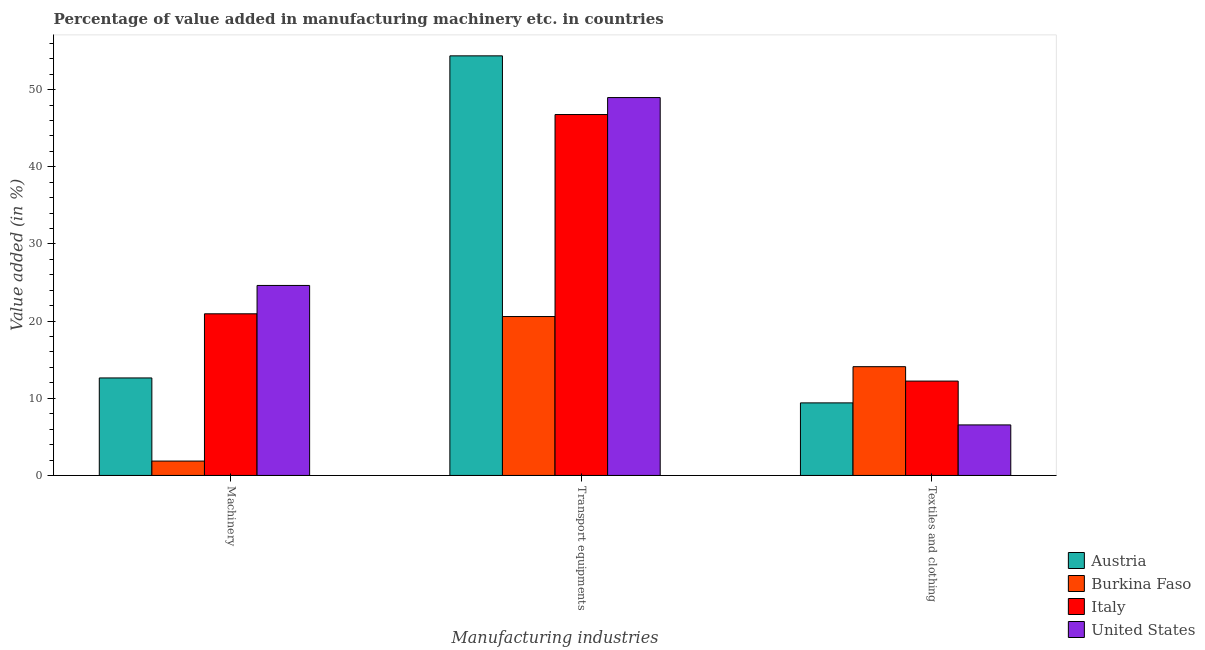How many groups of bars are there?
Provide a succinct answer. 3. How many bars are there on the 2nd tick from the left?
Ensure brevity in your answer.  4. What is the label of the 1st group of bars from the left?
Make the answer very short. Machinery. What is the value added in manufacturing machinery in United States?
Keep it short and to the point. 24.63. Across all countries, what is the maximum value added in manufacturing transport equipments?
Your answer should be compact. 54.38. Across all countries, what is the minimum value added in manufacturing machinery?
Give a very brief answer. 1.86. What is the total value added in manufacturing transport equipments in the graph?
Your answer should be very brief. 170.74. What is the difference between the value added in manufacturing machinery in Austria and that in Burkina Faso?
Provide a succinct answer. 10.77. What is the difference between the value added in manufacturing machinery in United States and the value added in manufacturing transport equipments in Austria?
Your answer should be compact. -29.76. What is the average value added in manufacturing textile and clothing per country?
Make the answer very short. 10.57. What is the difference between the value added in manufacturing transport equipments and value added in manufacturing textile and clothing in Burkina Faso?
Your answer should be compact. 6.5. In how many countries, is the value added in manufacturing transport equipments greater than 28 %?
Ensure brevity in your answer.  3. What is the ratio of the value added in manufacturing textile and clothing in United States to that in Italy?
Give a very brief answer. 0.54. Is the difference between the value added in manufacturing textile and clothing in United States and Austria greater than the difference between the value added in manufacturing transport equipments in United States and Austria?
Keep it short and to the point. Yes. What is the difference between the highest and the second highest value added in manufacturing textile and clothing?
Give a very brief answer. 1.87. What is the difference between the highest and the lowest value added in manufacturing machinery?
Keep it short and to the point. 22.76. What does the 3rd bar from the right in Textiles and clothing represents?
Provide a short and direct response. Burkina Faso. What is the difference between two consecutive major ticks on the Y-axis?
Make the answer very short. 10. Are the values on the major ticks of Y-axis written in scientific E-notation?
Your answer should be compact. No. Does the graph contain any zero values?
Give a very brief answer. No. Does the graph contain grids?
Offer a very short reply. No. How are the legend labels stacked?
Provide a short and direct response. Vertical. What is the title of the graph?
Make the answer very short. Percentage of value added in manufacturing machinery etc. in countries. Does "Afghanistan" appear as one of the legend labels in the graph?
Ensure brevity in your answer.  No. What is the label or title of the X-axis?
Make the answer very short. Manufacturing industries. What is the label or title of the Y-axis?
Make the answer very short. Value added (in %). What is the Value added (in %) in Austria in Machinery?
Keep it short and to the point. 12.64. What is the Value added (in %) in Burkina Faso in Machinery?
Give a very brief answer. 1.86. What is the Value added (in %) in Italy in Machinery?
Provide a succinct answer. 20.95. What is the Value added (in %) of United States in Machinery?
Give a very brief answer. 24.63. What is the Value added (in %) in Austria in Transport equipments?
Provide a short and direct response. 54.38. What is the Value added (in %) in Burkina Faso in Transport equipments?
Ensure brevity in your answer.  20.6. What is the Value added (in %) in Italy in Transport equipments?
Your answer should be very brief. 46.78. What is the Value added (in %) in United States in Transport equipments?
Make the answer very short. 48.98. What is the Value added (in %) in Austria in Textiles and clothing?
Your response must be concise. 9.4. What is the Value added (in %) in Burkina Faso in Textiles and clothing?
Your answer should be very brief. 14.1. What is the Value added (in %) in Italy in Textiles and clothing?
Offer a terse response. 12.23. What is the Value added (in %) in United States in Textiles and clothing?
Make the answer very short. 6.55. Across all Manufacturing industries, what is the maximum Value added (in %) in Austria?
Your answer should be compact. 54.38. Across all Manufacturing industries, what is the maximum Value added (in %) of Burkina Faso?
Provide a succinct answer. 20.6. Across all Manufacturing industries, what is the maximum Value added (in %) in Italy?
Keep it short and to the point. 46.78. Across all Manufacturing industries, what is the maximum Value added (in %) in United States?
Your answer should be compact. 48.98. Across all Manufacturing industries, what is the minimum Value added (in %) of Austria?
Your answer should be very brief. 9.4. Across all Manufacturing industries, what is the minimum Value added (in %) in Burkina Faso?
Make the answer very short. 1.86. Across all Manufacturing industries, what is the minimum Value added (in %) in Italy?
Ensure brevity in your answer.  12.23. Across all Manufacturing industries, what is the minimum Value added (in %) in United States?
Provide a succinct answer. 6.55. What is the total Value added (in %) of Austria in the graph?
Make the answer very short. 76.43. What is the total Value added (in %) in Burkina Faso in the graph?
Provide a succinct answer. 36.56. What is the total Value added (in %) in Italy in the graph?
Provide a short and direct response. 79.96. What is the total Value added (in %) of United States in the graph?
Your answer should be compact. 80.15. What is the difference between the Value added (in %) of Austria in Machinery and that in Transport equipments?
Offer a terse response. -41.75. What is the difference between the Value added (in %) in Burkina Faso in Machinery and that in Transport equipments?
Provide a short and direct response. -18.73. What is the difference between the Value added (in %) in Italy in Machinery and that in Transport equipments?
Offer a terse response. -25.83. What is the difference between the Value added (in %) of United States in Machinery and that in Transport equipments?
Provide a short and direct response. -24.35. What is the difference between the Value added (in %) in Austria in Machinery and that in Textiles and clothing?
Offer a terse response. 3.23. What is the difference between the Value added (in %) of Burkina Faso in Machinery and that in Textiles and clothing?
Provide a short and direct response. -12.23. What is the difference between the Value added (in %) in Italy in Machinery and that in Textiles and clothing?
Your answer should be compact. 8.72. What is the difference between the Value added (in %) in United States in Machinery and that in Textiles and clothing?
Provide a short and direct response. 18.08. What is the difference between the Value added (in %) in Austria in Transport equipments and that in Textiles and clothing?
Ensure brevity in your answer.  44.98. What is the difference between the Value added (in %) in Burkina Faso in Transport equipments and that in Textiles and clothing?
Give a very brief answer. 6.5. What is the difference between the Value added (in %) in Italy in Transport equipments and that in Textiles and clothing?
Make the answer very short. 34.55. What is the difference between the Value added (in %) of United States in Transport equipments and that in Textiles and clothing?
Keep it short and to the point. 42.43. What is the difference between the Value added (in %) of Austria in Machinery and the Value added (in %) of Burkina Faso in Transport equipments?
Offer a terse response. -7.96. What is the difference between the Value added (in %) in Austria in Machinery and the Value added (in %) in Italy in Transport equipments?
Make the answer very short. -34.14. What is the difference between the Value added (in %) of Austria in Machinery and the Value added (in %) of United States in Transport equipments?
Provide a succinct answer. -36.34. What is the difference between the Value added (in %) in Burkina Faso in Machinery and the Value added (in %) in Italy in Transport equipments?
Your answer should be compact. -44.91. What is the difference between the Value added (in %) in Burkina Faso in Machinery and the Value added (in %) in United States in Transport equipments?
Give a very brief answer. -47.11. What is the difference between the Value added (in %) of Italy in Machinery and the Value added (in %) of United States in Transport equipments?
Your answer should be very brief. -28.03. What is the difference between the Value added (in %) of Austria in Machinery and the Value added (in %) of Burkina Faso in Textiles and clothing?
Keep it short and to the point. -1.46. What is the difference between the Value added (in %) in Austria in Machinery and the Value added (in %) in Italy in Textiles and clothing?
Make the answer very short. 0.41. What is the difference between the Value added (in %) in Austria in Machinery and the Value added (in %) in United States in Textiles and clothing?
Your answer should be very brief. 6.09. What is the difference between the Value added (in %) in Burkina Faso in Machinery and the Value added (in %) in Italy in Textiles and clothing?
Your response must be concise. -10.37. What is the difference between the Value added (in %) of Burkina Faso in Machinery and the Value added (in %) of United States in Textiles and clothing?
Your answer should be compact. -4.69. What is the difference between the Value added (in %) of Italy in Machinery and the Value added (in %) of United States in Textiles and clothing?
Provide a short and direct response. 14.4. What is the difference between the Value added (in %) in Austria in Transport equipments and the Value added (in %) in Burkina Faso in Textiles and clothing?
Keep it short and to the point. 40.29. What is the difference between the Value added (in %) of Austria in Transport equipments and the Value added (in %) of Italy in Textiles and clothing?
Ensure brevity in your answer.  42.15. What is the difference between the Value added (in %) in Austria in Transport equipments and the Value added (in %) in United States in Textiles and clothing?
Your response must be concise. 47.83. What is the difference between the Value added (in %) of Burkina Faso in Transport equipments and the Value added (in %) of Italy in Textiles and clothing?
Provide a succinct answer. 8.37. What is the difference between the Value added (in %) in Burkina Faso in Transport equipments and the Value added (in %) in United States in Textiles and clothing?
Make the answer very short. 14.05. What is the difference between the Value added (in %) of Italy in Transport equipments and the Value added (in %) of United States in Textiles and clothing?
Keep it short and to the point. 40.23. What is the average Value added (in %) in Austria per Manufacturing industries?
Keep it short and to the point. 25.48. What is the average Value added (in %) of Burkina Faso per Manufacturing industries?
Offer a very short reply. 12.19. What is the average Value added (in %) of Italy per Manufacturing industries?
Make the answer very short. 26.65. What is the average Value added (in %) of United States per Manufacturing industries?
Keep it short and to the point. 26.72. What is the difference between the Value added (in %) in Austria and Value added (in %) in Burkina Faso in Machinery?
Provide a succinct answer. 10.77. What is the difference between the Value added (in %) in Austria and Value added (in %) in Italy in Machinery?
Your response must be concise. -8.31. What is the difference between the Value added (in %) in Austria and Value added (in %) in United States in Machinery?
Provide a succinct answer. -11.99. What is the difference between the Value added (in %) in Burkina Faso and Value added (in %) in Italy in Machinery?
Offer a terse response. -19.09. What is the difference between the Value added (in %) in Burkina Faso and Value added (in %) in United States in Machinery?
Your answer should be compact. -22.76. What is the difference between the Value added (in %) in Italy and Value added (in %) in United States in Machinery?
Keep it short and to the point. -3.68. What is the difference between the Value added (in %) in Austria and Value added (in %) in Burkina Faso in Transport equipments?
Ensure brevity in your answer.  33.79. What is the difference between the Value added (in %) in Austria and Value added (in %) in Italy in Transport equipments?
Provide a succinct answer. 7.61. What is the difference between the Value added (in %) of Austria and Value added (in %) of United States in Transport equipments?
Your answer should be compact. 5.41. What is the difference between the Value added (in %) of Burkina Faso and Value added (in %) of Italy in Transport equipments?
Your answer should be compact. -26.18. What is the difference between the Value added (in %) of Burkina Faso and Value added (in %) of United States in Transport equipments?
Offer a very short reply. -28.38. What is the difference between the Value added (in %) of Italy and Value added (in %) of United States in Transport equipments?
Your response must be concise. -2.2. What is the difference between the Value added (in %) of Austria and Value added (in %) of Burkina Faso in Textiles and clothing?
Ensure brevity in your answer.  -4.69. What is the difference between the Value added (in %) in Austria and Value added (in %) in Italy in Textiles and clothing?
Ensure brevity in your answer.  -2.82. What is the difference between the Value added (in %) in Austria and Value added (in %) in United States in Textiles and clothing?
Provide a short and direct response. 2.86. What is the difference between the Value added (in %) in Burkina Faso and Value added (in %) in Italy in Textiles and clothing?
Your answer should be compact. 1.87. What is the difference between the Value added (in %) in Burkina Faso and Value added (in %) in United States in Textiles and clothing?
Ensure brevity in your answer.  7.55. What is the difference between the Value added (in %) of Italy and Value added (in %) of United States in Textiles and clothing?
Your answer should be compact. 5.68. What is the ratio of the Value added (in %) in Austria in Machinery to that in Transport equipments?
Provide a short and direct response. 0.23. What is the ratio of the Value added (in %) in Burkina Faso in Machinery to that in Transport equipments?
Provide a succinct answer. 0.09. What is the ratio of the Value added (in %) in Italy in Machinery to that in Transport equipments?
Your answer should be very brief. 0.45. What is the ratio of the Value added (in %) of United States in Machinery to that in Transport equipments?
Give a very brief answer. 0.5. What is the ratio of the Value added (in %) of Austria in Machinery to that in Textiles and clothing?
Your response must be concise. 1.34. What is the ratio of the Value added (in %) of Burkina Faso in Machinery to that in Textiles and clothing?
Ensure brevity in your answer.  0.13. What is the ratio of the Value added (in %) in Italy in Machinery to that in Textiles and clothing?
Provide a short and direct response. 1.71. What is the ratio of the Value added (in %) in United States in Machinery to that in Textiles and clothing?
Ensure brevity in your answer.  3.76. What is the ratio of the Value added (in %) of Austria in Transport equipments to that in Textiles and clothing?
Make the answer very short. 5.78. What is the ratio of the Value added (in %) of Burkina Faso in Transport equipments to that in Textiles and clothing?
Your response must be concise. 1.46. What is the ratio of the Value added (in %) of Italy in Transport equipments to that in Textiles and clothing?
Give a very brief answer. 3.83. What is the ratio of the Value added (in %) in United States in Transport equipments to that in Textiles and clothing?
Keep it short and to the point. 7.48. What is the difference between the highest and the second highest Value added (in %) in Austria?
Provide a succinct answer. 41.75. What is the difference between the highest and the second highest Value added (in %) of Burkina Faso?
Keep it short and to the point. 6.5. What is the difference between the highest and the second highest Value added (in %) in Italy?
Offer a terse response. 25.83. What is the difference between the highest and the second highest Value added (in %) of United States?
Offer a very short reply. 24.35. What is the difference between the highest and the lowest Value added (in %) of Austria?
Your answer should be compact. 44.98. What is the difference between the highest and the lowest Value added (in %) of Burkina Faso?
Keep it short and to the point. 18.73. What is the difference between the highest and the lowest Value added (in %) of Italy?
Provide a short and direct response. 34.55. What is the difference between the highest and the lowest Value added (in %) in United States?
Offer a very short reply. 42.43. 